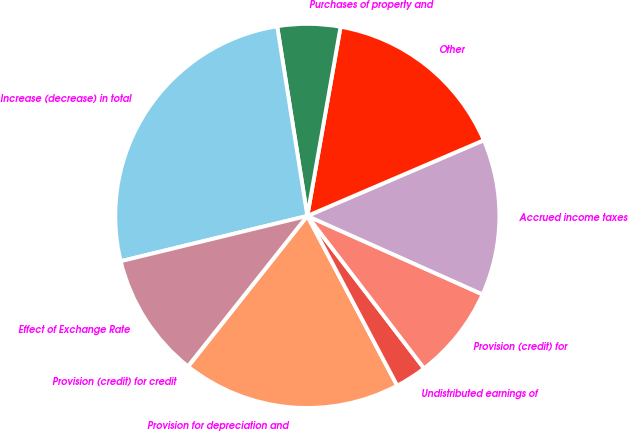<chart> <loc_0><loc_0><loc_500><loc_500><pie_chart><fcel>Provision (credit) for credit<fcel>Provision for depreciation and<fcel>Undistributed earnings of<fcel>Provision (credit) for<fcel>Accrued income taxes<fcel>Other<fcel>Purchases of property and<fcel>Increase (decrease) in total<fcel>Effect of Exchange Rate<nl><fcel>0.03%<fcel>18.4%<fcel>2.65%<fcel>7.9%<fcel>13.15%<fcel>15.78%<fcel>5.28%<fcel>26.28%<fcel>10.53%<nl></chart> 